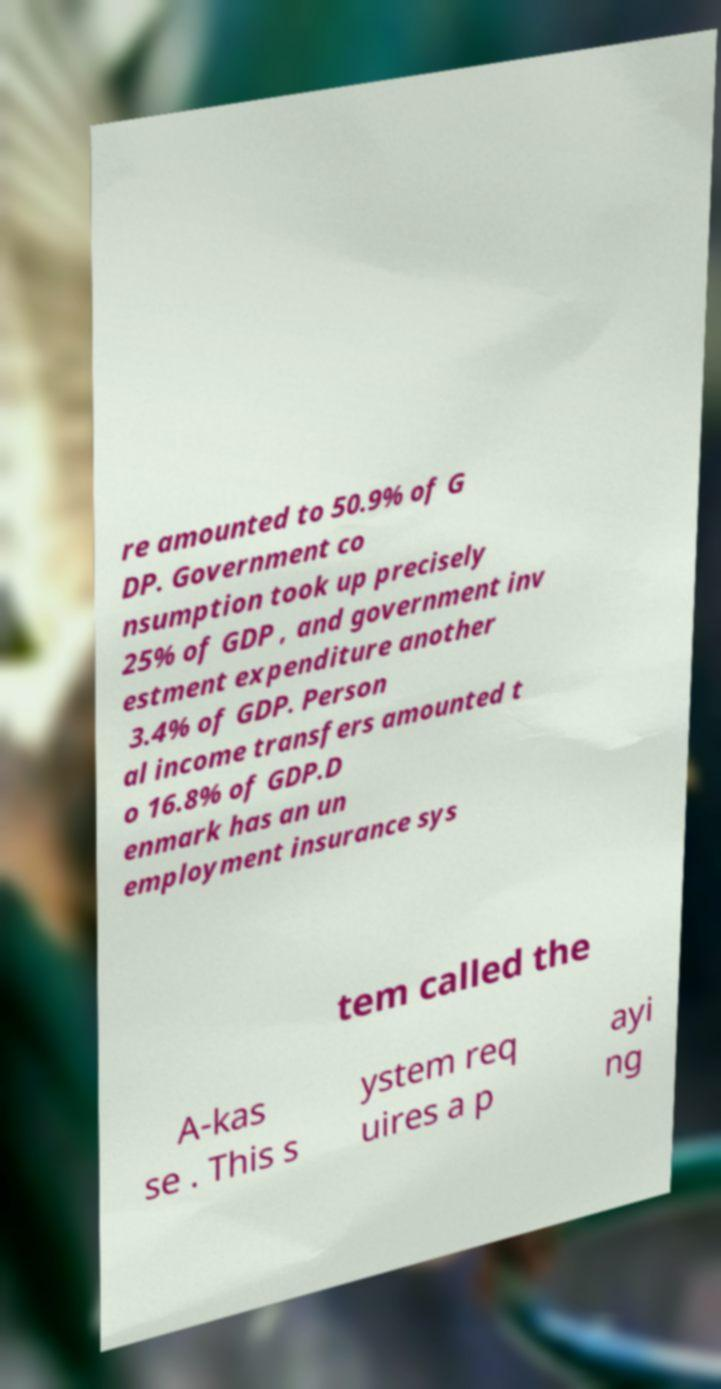Can you accurately transcribe the text from the provided image for me? re amounted to 50.9% of G DP. Government co nsumption took up precisely 25% of GDP , and government inv estment expenditure another 3.4% of GDP. Person al income transfers amounted t o 16.8% of GDP.D enmark has an un employment insurance sys tem called the A-kas se . This s ystem req uires a p ayi ng 